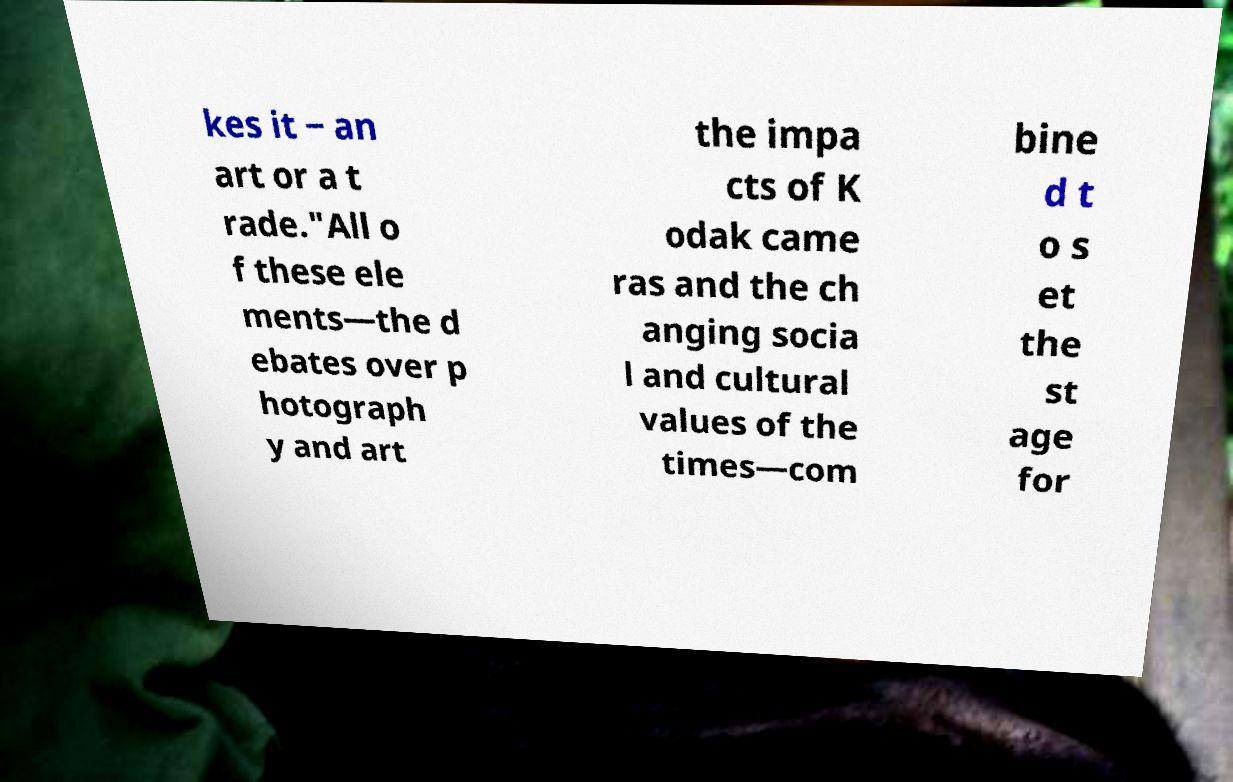Can you read and provide the text displayed in the image?This photo seems to have some interesting text. Can you extract and type it out for me? kes it ‒ an art or a t rade."All o f these ele ments—the d ebates over p hotograph y and art the impa cts of K odak came ras and the ch anging socia l and cultural values of the times—com bine d t o s et the st age for 